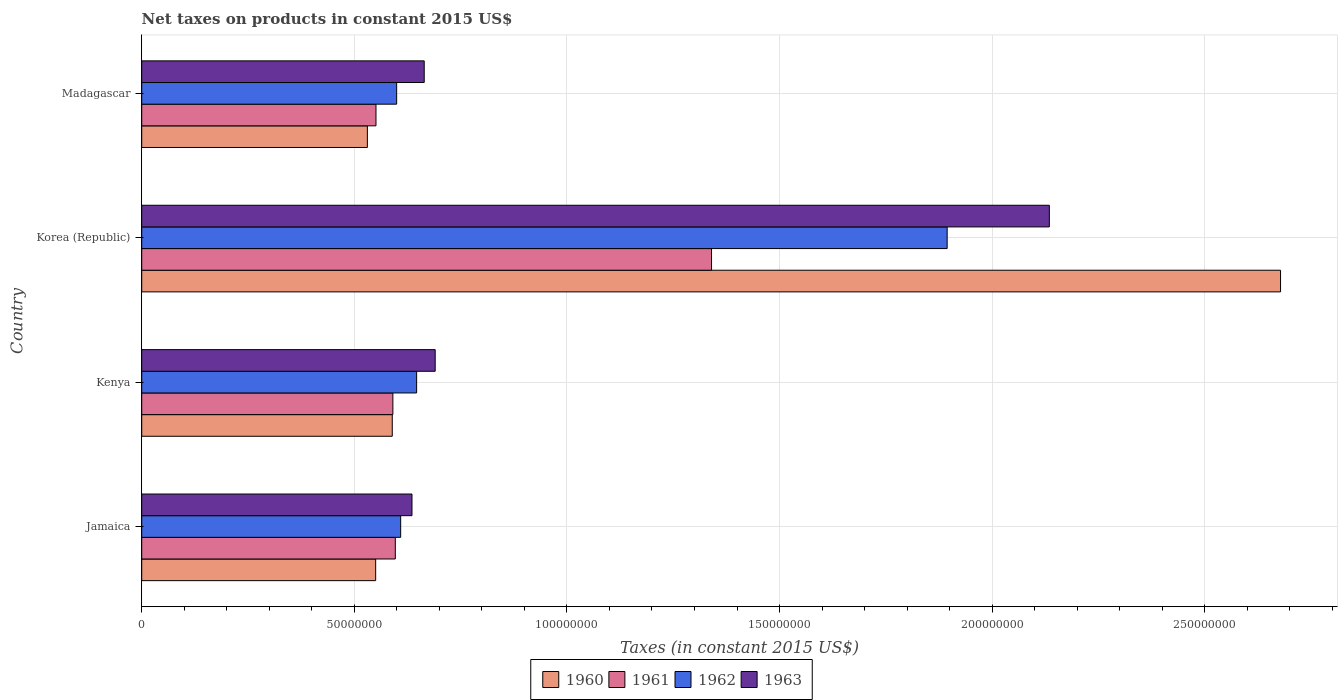Are the number of bars per tick equal to the number of legend labels?
Give a very brief answer. Yes. Are the number of bars on each tick of the Y-axis equal?
Your response must be concise. Yes. How many bars are there on the 3rd tick from the top?
Give a very brief answer. 4. What is the label of the 4th group of bars from the top?
Offer a very short reply. Jamaica. In how many cases, is the number of bars for a given country not equal to the number of legend labels?
Make the answer very short. 0. What is the net taxes on products in 1962 in Korea (Republic)?
Provide a succinct answer. 1.89e+08. Across all countries, what is the maximum net taxes on products in 1961?
Ensure brevity in your answer.  1.34e+08. Across all countries, what is the minimum net taxes on products in 1963?
Give a very brief answer. 6.36e+07. In which country was the net taxes on products in 1960 maximum?
Keep it short and to the point. Korea (Republic). In which country was the net taxes on products in 1960 minimum?
Keep it short and to the point. Madagascar. What is the total net taxes on products in 1962 in the graph?
Offer a very short reply. 3.75e+08. What is the difference between the net taxes on products in 1960 in Korea (Republic) and that in Madagascar?
Provide a succinct answer. 2.15e+08. What is the difference between the net taxes on products in 1960 in Jamaica and the net taxes on products in 1961 in Madagascar?
Provide a short and direct response. -7.48e+04. What is the average net taxes on products in 1963 per country?
Give a very brief answer. 1.03e+08. What is the difference between the net taxes on products in 1962 and net taxes on products in 1961 in Korea (Republic)?
Offer a very short reply. 5.54e+07. What is the ratio of the net taxes on products in 1963 in Korea (Republic) to that in Madagascar?
Make the answer very short. 3.21. What is the difference between the highest and the second highest net taxes on products in 1961?
Your answer should be very brief. 7.44e+07. What is the difference between the highest and the lowest net taxes on products in 1961?
Your answer should be very brief. 7.89e+07. In how many countries, is the net taxes on products in 1961 greater than the average net taxes on products in 1961 taken over all countries?
Offer a very short reply. 1. What does the 2nd bar from the bottom in Jamaica represents?
Offer a very short reply. 1961. Is it the case that in every country, the sum of the net taxes on products in 1963 and net taxes on products in 1962 is greater than the net taxes on products in 1961?
Your answer should be very brief. Yes. How many bars are there?
Provide a succinct answer. 16. How many countries are there in the graph?
Offer a terse response. 4. Are the values on the major ticks of X-axis written in scientific E-notation?
Make the answer very short. No. What is the title of the graph?
Your answer should be very brief. Net taxes on products in constant 2015 US$. What is the label or title of the X-axis?
Offer a terse response. Taxes (in constant 2015 US$). What is the label or title of the Y-axis?
Give a very brief answer. Country. What is the Taxes (in constant 2015 US$) in 1960 in Jamaica?
Offer a terse response. 5.50e+07. What is the Taxes (in constant 2015 US$) in 1961 in Jamaica?
Offer a terse response. 5.96e+07. What is the Taxes (in constant 2015 US$) of 1962 in Jamaica?
Offer a terse response. 6.09e+07. What is the Taxes (in constant 2015 US$) of 1963 in Jamaica?
Ensure brevity in your answer.  6.36e+07. What is the Taxes (in constant 2015 US$) in 1960 in Kenya?
Offer a terse response. 5.89e+07. What is the Taxes (in constant 2015 US$) of 1961 in Kenya?
Make the answer very short. 5.91e+07. What is the Taxes (in constant 2015 US$) in 1962 in Kenya?
Your answer should be very brief. 6.47e+07. What is the Taxes (in constant 2015 US$) in 1963 in Kenya?
Your answer should be very brief. 6.90e+07. What is the Taxes (in constant 2015 US$) in 1960 in Korea (Republic)?
Ensure brevity in your answer.  2.68e+08. What is the Taxes (in constant 2015 US$) in 1961 in Korea (Republic)?
Make the answer very short. 1.34e+08. What is the Taxes (in constant 2015 US$) of 1962 in Korea (Republic)?
Your answer should be very brief. 1.89e+08. What is the Taxes (in constant 2015 US$) of 1963 in Korea (Republic)?
Your answer should be compact. 2.13e+08. What is the Taxes (in constant 2015 US$) of 1960 in Madagascar?
Make the answer very short. 5.31e+07. What is the Taxes (in constant 2015 US$) of 1961 in Madagascar?
Offer a terse response. 5.51e+07. What is the Taxes (in constant 2015 US$) in 1962 in Madagascar?
Your answer should be compact. 6.00e+07. What is the Taxes (in constant 2015 US$) in 1963 in Madagascar?
Give a very brief answer. 6.64e+07. Across all countries, what is the maximum Taxes (in constant 2015 US$) in 1960?
Offer a very short reply. 2.68e+08. Across all countries, what is the maximum Taxes (in constant 2015 US$) in 1961?
Your response must be concise. 1.34e+08. Across all countries, what is the maximum Taxes (in constant 2015 US$) of 1962?
Offer a very short reply. 1.89e+08. Across all countries, what is the maximum Taxes (in constant 2015 US$) in 1963?
Provide a short and direct response. 2.13e+08. Across all countries, what is the minimum Taxes (in constant 2015 US$) of 1960?
Ensure brevity in your answer.  5.31e+07. Across all countries, what is the minimum Taxes (in constant 2015 US$) of 1961?
Your answer should be compact. 5.51e+07. Across all countries, what is the minimum Taxes (in constant 2015 US$) of 1962?
Your answer should be very brief. 6.00e+07. Across all countries, what is the minimum Taxes (in constant 2015 US$) of 1963?
Provide a short and direct response. 6.36e+07. What is the total Taxes (in constant 2015 US$) in 1960 in the graph?
Your answer should be very brief. 4.35e+08. What is the total Taxes (in constant 2015 US$) in 1961 in the graph?
Offer a very short reply. 3.08e+08. What is the total Taxes (in constant 2015 US$) in 1962 in the graph?
Give a very brief answer. 3.75e+08. What is the total Taxes (in constant 2015 US$) of 1963 in the graph?
Make the answer very short. 4.12e+08. What is the difference between the Taxes (in constant 2015 US$) of 1960 in Jamaica and that in Kenya?
Provide a short and direct response. -3.91e+06. What is the difference between the Taxes (in constant 2015 US$) in 1961 in Jamaica and that in Kenya?
Give a very brief answer. 5.74e+05. What is the difference between the Taxes (in constant 2015 US$) of 1962 in Jamaica and that in Kenya?
Offer a very short reply. -3.75e+06. What is the difference between the Taxes (in constant 2015 US$) of 1963 in Jamaica and that in Kenya?
Offer a terse response. -5.46e+06. What is the difference between the Taxes (in constant 2015 US$) of 1960 in Jamaica and that in Korea (Republic)?
Ensure brevity in your answer.  -2.13e+08. What is the difference between the Taxes (in constant 2015 US$) of 1961 in Jamaica and that in Korea (Republic)?
Offer a terse response. -7.44e+07. What is the difference between the Taxes (in constant 2015 US$) of 1962 in Jamaica and that in Korea (Republic)?
Provide a succinct answer. -1.29e+08. What is the difference between the Taxes (in constant 2015 US$) in 1963 in Jamaica and that in Korea (Republic)?
Your response must be concise. -1.50e+08. What is the difference between the Taxes (in constant 2015 US$) in 1960 in Jamaica and that in Madagascar?
Offer a terse response. 1.95e+06. What is the difference between the Taxes (in constant 2015 US$) in 1961 in Jamaica and that in Madagascar?
Offer a very short reply. 4.55e+06. What is the difference between the Taxes (in constant 2015 US$) of 1962 in Jamaica and that in Madagascar?
Keep it short and to the point. 9.44e+05. What is the difference between the Taxes (in constant 2015 US$) of 1963 in Jamaica and that in Madagascar?
Ensure brevity in your answer.  -2.88e+06. What is the difference between the Taxes (in constant 2015 US$) in 1960 in Kenya and that in Korea (Republic)?
Give a very brief answer. -2.09e+08. What is the difference between the Taxes (in constant 2015 US$) of 1961 in Kenya and that in Korea (Republic)?
Give a very brief answer. -7.49e+07. What is the difference between the Taxes (in constant 2015 US$) in 1962 in Kenya and that in Korea (Republic)?
Offer a terse response. -1.25e+08. What is the difference between the Taxes (in constant 2015 US$) of 1963 in Kenya and that in Korea (Republic)?
Make the answer very short. -1.44e+08. What is the difference between the Taxes (in constant 2015 US$) of 1960 in Kenya and that in Madagascar?
Your response must be concise. 5.86e+06. What is the difference between the Taxes (in constant 2015 US$) of 1961 in Kenya and that in Madagascar?
Keep it short and to the point. 3.97e+06. What is the difference between the Taxes (in constant 2015 US$) in 1962 in Kenya and that in Madagascar?
Keep it short and to the point. 4.70e+06. What is the difference between the Taxes (in constant 2015 US$) of 1963 in Kenya and that in Madagascar?
Offer a very short reply. 2.58e+06. What is the difference between the Taxes (in constant 2015 US$) of 1960 in Korea (Republic) and that in Madagascar?
Ensure brevity in your answer.  2.15e+08. What is the difference between the Taxes (in constant 2015 US$) of 1961 in Korea (Republic) and that in Madagascar?
Provide a short and direct response. 7.89e+07. What is the difference between the Taxes (in constant 2015 US$) of 1962 in Korea (Republic) and that in Madagascar?
Offer a very short reply. 1.29e+08. What is the difference between the Taxes (in constant 2015 US$) in 1963 in Korea (Republic) and that in Madagascar?
Ensure brevity in your answer.  1.47e+08. What is the difference between the Taxes (in constant 2015 US$) of 1960 in Jamaica and the Taxes (in constant 2015 US$) of 1961 in Kenya?
Give a very brief answer. -4.05e+06. What is the difference between the Taxes (in constant 2015 US$) of 1960 in Jamaica and the Taxes (in constant 2015 US$) of 1962 in Kenya?
Your answer should be very brief. -9.63e+06. What is the difference between the Taxes (in constant 2015 US$) in 1960 in Jamaica and the Taxes (in constant 2015 US$) in 1963 in Kenya?
Your answer should be very brief. -1.40e+07. What is the difference between the Taxes (in constant 2015 US$) in 1961 in Jamaica and the Taxes (in constant 2015 US$) in 1962 in Kenya?
Your answer should be very brief. -5.01e+06. What is the difference between the Taxes (in constant 2015 US$) in 1961 in Jamaica and the Taxes (in constant 2015 US$) in 1963 in Kenya?
Offer a very short reply. -9.38e+06. What is the difference between the Taxes (in constant 2015 US$) of 1962 in Jamaica and the Taxes (in constant 2015 US$) of 1963 in Kenya?
Offer a terse response. -8.12e+06. What is the difference between the Taxes (in constant 2015 US$) in 1960 in Jamaica and the Taxes (in constant 2015 US$) in 1961 in Korea (Republic)?
Keep it short and to the point. -7.90e+07. What is the difference between the Taxes (in constant 2015 US$) of 1960 in Jamaica and the Taxes (in constant 2015 US$) of 1962 in Korea (Republic)?
Give a very brief answer. -1.34e+08. What is the difference between the Taxes (in constant 2015 US$) in 1960 in Jamaica and the Taxes (in constant 2015 US$) in 1963 in Korea (Republic)?
Make the answer very short. -1.58e+08. What is the difference between the Taxes (in constant 2015 US$) of 1961 in Jamaica and the Taxes (in constant 2015 US$) of 1962 in Korea (Republic)?
Offer a very short reply. -1.30e+08. What is the difference between the Taxes (in constant 2015 US$) of 1961 in Jamaica and the Taxes (in constant 2015 US$) of 1963 in Korea (Republic)?
Give a very brief answer. -1.54e+08. What is the difference between the Taxes (in constant 2015 US$) in 1962 in Jamaica and the Taxes (in constant 2015 US$) in 1963 in Korea (Republic)?
Give a very brief answer. -1.53e+08. What is the difference between the Taxes (in constant 2015 US$) of 1960 in Jamaica and the Taxes (in constant 2015 US$) of 1961 in Madagascar?
Keep it short and to the point. -7.48e+04. What is the difference between the Taxes (in constant 2015 US$) of 1960 in Jamaica and the Taxes (in constant 2015 US$) of 1962 in Madagascar?
Make the answer very short. -4.94e+06. What is the difference between the Taxes (in constant 2015 US$) in 1960 in Jamaica and the Taxes (in constant 2015 US$) in 1963 in Madagascar?
Your answer should be very brief. -1.14e+07. What is the difference between the Taxes (in constant 2015 US$) of 1961 in Jamaica and the Taxes (in constant 2015 US$) of 1962 in Madagascar?
Offer a very short reply. -3.16e+05. What is the difference between the Taxes (in constant 2015 US$) in 1961 in Jamaica and the Taxes (in constant 2015 US$) in 1963 in Madagascar?
Provide a short and direct response. -6.80e+06. What is the difference between the Taxes (in constant 2015 US$) of 1962 in Jamaica and the Taxes (in constant 2015 US$) of 1963 in Madagascar?
Provide a short and direct response. -5.54e+06. What is the difference between the Taxes (in constant 2015 US$) in 1960 in Kenya and the Taxes (in constant 2015 US$) in 1961 in Korea (Republic)?
Ensure brevity in your answer.  -7.51e+07. What is the difference between the Taxes (in constant 2015 US$) in 1960 in Kenya and the Taxes (in constant 2015 US$) in 1962 in Korea (Republic)?
Your answer should be compact. -1.31e+08. What is the difference between the Taxes (in constant 2015 US$) in 1960 in Kenya and the Taxes (in constant 2015 US$) in 1963 in Korea (Republic)?
Provide a succinct answer. -1.55e+08. What is the difference between the Taxes (in constant 2015 US$) in 1961 in Kenya and the Taxes (in constant 2015 US$) in 1962 in Korea (Republic)?
Your response must be concise. -1.30e+08. What is the difference between the Taxes (in constant 2015 US$) of 1961 in Kenya and the Taxes (in constant 2015 US$) of 1963 in Korea (Republic)?
Your answer should be compact. -1.54e+08. What is the difference between the Taxes (in constant 2015 US$) of 1962 in Kenya and the Taxes (in constant 2015 US$) of 1963 in Korea (Republic)?
Make the answer very short. -1.49e+08. What is the difference between the Taxes (in constant 2015 US$) in 1960 in Kenya and the Taxes (in constant 2015 US$) in 1961 in Madagascar?
Your answer should be compact. 3.83e+06. What is the difference between the Taxes (in constant 2015 US$) in 1960 in Kenya and the Taxes (in constant 2015 US$) in 1962 in Madagascar?
Your answer should be very brief. -1.03e+06. What is the difference between the Taxes (in constant 2015 US$) of 1960 in Kenya and the Taxes (in constant 2015 US$) of 1963 in Madagascar?
Your answer should be very brief. -7.51e+06. What is the difference between the Taxes (in constant 2015 US$) of 1961 in Kenya and the Taxes (in constant 2015 US$) of 1962 in Madagascar?
Your response must be concise. -8.90e+05. What is the difference between the Taxes (in constant 2015 US$) of 1961 in Kenya and the Taxes (in constant 2015 US$) of 1963 in Madagascar?
Your response must be concise. -7.37e+06. What is the difference between the Taxes (in constant 2015 US$) of 1962 in Kenya and the Taxes (in constant 2015 US$) of 1963 in Madagascar?
Provide a succinct answer. -1.79e+06. What is the difference between the Taxes (in constant 2015 US$) in 1960 in Korea (Republic) and the Taxes (in constant 2015 US$) in 1961 in Madagascar?
Offer a terse response. 2.13e+08. What is the difference between the Taxes (in constant 2015 US$) of 1960 in Korea (Republic) and the Taxes (in constant 2015 US$) of 1962 in Madagascar?
Provide a short and direct response. 2.08e+08. What is the difference between the Taxes (in constant 2015 US$) of 1960 in Korea (Republic) and the Taxes (in constant 2015 US$) of 1963 in Madagascar?
Your response must be concise. 2.01e+08. What is the difference between the Taxes (in constant 2015 US$) of 1961 in Korea (Republic) and the Taxes (in constant 2015 US$) of 1962 in Madagascar?
Your answer should be very brief. 7.41e+07. What is the difference between the Taxes (in constant 2015 US$) in 1961 in Korea (Republic) and the Taxes (in constant 2015 US$) in 1963 in Madagascar?
Keep it short and to the point. 6.76e+07. What is the difference between the Taxes (in constant 2015 US$) in 1962 in Korea (Republic) and the Taxes (in constant 2015 US$) in 1963 in Madagascar?
Keep it short and to the point. 1.23e+08. What is the average Taxes (in constant 2015 US$) in 1960 per country?
Keep it short and to the point. 1.09e+08. What is the average Taxes (in constant 2015 US$) of 1961 per country?
Your response must be concise. 7.70e+07. What is the average Taxes (in constant 2015 US$) of 1962 per country?
Offer a terse response. 9.37e+07. What is the average Taxes (in constant 2015 US$) of 1963 per country?
Ensure brevity in your answer.  1.03e+08. What is the difference between the Taxes (in constant 2015 US$) of 1960 and Taxes (in constant 2015 US$) of 1961 in Jamaica?
Give a very brief answer. -4.62e+06. What is the difference between the Taxes (in constant 2015 US$) of 1960 and Taxes (in constant 2015 US$) of 1962 in Jamaica?
Offer a terse response. -5.88e+06. What is the difference between the Taxes (in constant 2015 US$) of 1960 and Taxes (in constant 2015 US$) of 1963 in Jamaica?
Give a very brief answer. -8.54e+06. What is the difference between the Taxes (in constant 2015 US$) of 1961 and Taxes (in constant 2015 US$) of 1962 in Jamaica?
Provide a succinct answer. -1.26e+06. What is the difference between the Taxes (in constant 2015 US$) of 1961 and Taxes (in constant 2015 US$) of 1963 in Jamaica?
Provide a succinct answer. -3.92e+06. What is the difference between the Taxes (in constant 2015 US$) in 1962 and Taxes (in constant 2015 US$) in 1963 in Jamaica?
Your answer should be compact. -2.66e+06. What is the difference between the Taxes (in constant 2015 US$) in 1960 and Taxes (in constant 2015 US$) in 1961 in Kenya?
Give a very brief answer. -1.40e+05. What is the difference between the Taxes (in constant 2015 US$) in 1960 and Taxes (in constant 2015 US$) in 1962 in Kenya?
Your response must be concise. -5.73e+06. What is the difference between the Taxes (in constant 2015 US$) of 1960 and Taxes (in constant 2015 US$) of 1963 in Kenya?
Ensure brevity in your answer.  -1.01e+07. What is the difference between the Taxes (in constant 2015 US$) in 1961 and Taxes (in constant 2015 US$) in 1962 in Kenya?
Make the answer very short. -5.59e+06. What is the difference between the Taxes (in constant 2015 US$) of 1961 and Taxes (in constant 2015 US$) of 1963 in Kenya?
Provide a succinct answer. -9.95e+06. What is the difference between the Taxes (in constant 2015 US$) in 1962 and Taxes (in constant 2015 US$) in 1963 in Kenya?
Your answer should be very brief. -4.37e+06. What is the difference between the Taxes (in constant 2015 US$) in 1960 and Taxes (in constant 2015 US$) in 1961 in Korea (Republic)?
Provide a succinct answer. 1.34e+08. What is the difference between the Taxes (in constant 2015 US$) of 1960 and Taxes (in constant 2015 US$) of 1962 in Korea (Republic)?
Ensure brevity in your answer.  7.84e+07. What is the difference between the Taxes (in constant 2015 US$) in 1960 and Taxes (in constant 2015 US$) in 1963 in Korea (Republic)?
Keep it short and to the point. 5.44e+07. What is the difference between the Taxes (in constant 2015 US$) of 1961 and Taxes (in constant 2015 US$) of 1962 in Korea (Republic)?
Offer a terse response. -5.54e+07. What is the difference between the Taxes (in constant 2015 US$) of 1961 and Taxes (in constant 2015 US$) of 1963 in Korea (Republic)?
Your answer should be compact. -7.94e+07. What is the difference between the Taxes (in constant 2015 US$) in 1962 and Taxes (in constant 2015 US$) in 1963 in Korea (Republic)?
Ensure brevity in your answer.  -2.40e+07. What is the difference between the Taxes (in constant 2015 US$) in 1960 and Taxes (in constant 2015 US$) in 1961 in Madagascar?
Provide a short and direct response. -2.03e+06. What is the difference between the Taxes (in constant 2015 US$) of 1960 and Taxes (in constant 2015 US$) of 1962 in Madagascar?
Provide a short and direct response. -6.89e+06. What is the difference between the Taxes (in constant 2015 US$) of 1960 and Taxes (in constant 2015 US$) of 1963 in Madagascar?
Offer a very short reply. -1.34e+07. What is the difference between the Taxes (in constant 2015 US$) in 1961 and Taxes (in constant 2015 US$) in 1962 in Madagascar?
Ensure brevity in your answer.  -4.86e+06. What is the difference between the Taxes (in constant 2015 US$) in 1961 and Taxes (in constant 2015 US$) in 1963 in Madagascar?
Your answer should be compact. -1.13e+07. What is the difference between the Taxes (in constant 2015 US$) of 1962 and Taxes (in constant 2015 US$) of 1963 in Madagascar?
Ensure brevity in your answer.  -6.48e+06. What is the ratio of the Taxes (in constant 2015 US$) in 1960 in Jamaica to that in Kenya?
Give a very brief answer. 0.93. What is the ratio of the Taxes (in constant 2015 US$) of 1961 in Jamaica to that in Kenya?
Offer a terse response. 1.01. What is the ratio of the Taxes (in constant 2015 US$) of 1962 in Jamaica to that in Kenya?
Offer a very short reply. 0.94. What is the ratio of the Taxes (in constant 2015 US$) of 1963 in Jamaica to that in Kenya?
Offer a very short reply. 0.92. What is the ratio of the Taxes (in constant 2015 US$) of 1960 in Jamaica to that in Korea (Republic)?
Your response must be concise. 0.21. What is the ratio of the Taxes (in constant 2015 US$) of 1961 in Jamaica to that in Korea (Republic)?
Keep it short and to the point. 0.45. What is the ratio of the Taxes (in constant 2015 US$) of 1962 in Jamaica to that in Korea (Republic)?
Your response must be concise. 0.32. What is the ratio of the Taxes (in constant 2015 US$) of 1963 in Jamaica to that in Korea (Republic)?
Ensure brevity in your answer.  0.3. What is the ratio of the Taxes (in constant 2015 US$) of 1960 in Jamaica to that in Madagascar?
Offer a terse response. 1.04. What is the ratio of the Taxes (in constant 2015 US$) of 1961 in Jamaica to that in Madagascar?
Offer a very short reply. 1.08. What is the ratio of the Taxes (in constant 2015 US$) in 1962 in Jamaica to that in Madagascar?
Make the answer very short. 1.02. What is the ratio of the Taxes (in constant 2015 US$) in 1963 in Jamaica to that in Madagascar?
Your answer should be very brief. 0.96. What is the ratio of the Taxes (in constant 2015 US$) of 1960 in Kenya to that in Korea (Republic)?
Your answer should be very brief. 0.22. What is the ratio of the Taxes (in constant 2015 US$) in 1961 in Kenya to that in Korea (Republic)?
Your answer should be compact. 0.44. What is the ratio of the Taxes (in constant 2015 US$) in 1962 in Kenya to that in Korea (Republic)?
Give a very brief answer. 0.34. What is the ratio of the Taxes (in constant 2015 US$) in 1963 in Kenya to that in Korea (Republic)?
Your response must be concise. 0.32. What is the ratio of the Taxes (in constant 2015 US$) of 1960 in Kenya to that in Madagascar?
Your answer should be compact. 1.11. What is the ratio of the Taxes (in constant 2015 US$) of 1961 in Kenya to that in Madagascar?
Provide a succinct answer. 1.07. What is the ratio of the Taxes (in constant 2015 US$) of 1962 in Kenya to that in Madagascar?
Offer a terse response. 1.08. What is the ratio of the Taxes (in constant 2015 US$) in 1963 in Kenya to that in Madagascar?
Offer a terse response. 1.04. What is the ratio of the Taxes (in constant 2015 US$) of 1960 in Korea (Republic) to that in Madagascar?
Make the answer very short. 5.05. What is the ratio of the Taxes (in constant 2015 US$) in 1961 in Korea (Republic) to that in Madagascar?
Offer a terse response. 2.43. What is the ratio of the Taxes (in constant 2015 US$) of 1962 in Korea (Republic) to that in Madagascar?
Offer a very short reply. 3.16. What is the ratio of the Taxes (in constant 2015 US$) in 1963 in Korea (Republic) to that in Madagascar?
Ensure brevity in your answer.  3.21. What is the difference between the highest and the second highest Taxes (in constant 2015 US$) in 1960?
Your answer should be compact. 2.09e+08. What is the difference between the highest and the second highest Taxes (in constant 2015 US$) of 1961?
Make the answer very short. 7.44e+07. What is the difference between the highest and the second highest Taxes (in constant 2015 US$) of 1962?
Keep it short and to the point. 1.25e+08. What is the difference between the highest and the second highest Taxes (in constant 2015 US$) of 1963?
Offer a very short reply. 1.44e+08. What is the difference between the highest and the lowest Taxes (in constant 2015 US$) in 1960?
Ensure brevity in your answer.  2.15e+08. What is the difference between the highest and the lowest Taxes (in constant 2015 US$) of 1961?
Your answer should be very brief. 7.89e+07. What is the difference between the highest and the lowest Taxes (in constant 2015 US$) of 1962?
Make the answer very short. 1.29e+08. What is the difference between the highest and the lowest Taxes (in constant 2015 US$) of 1963?
Provide a short and direct response. 1.50e+08. 